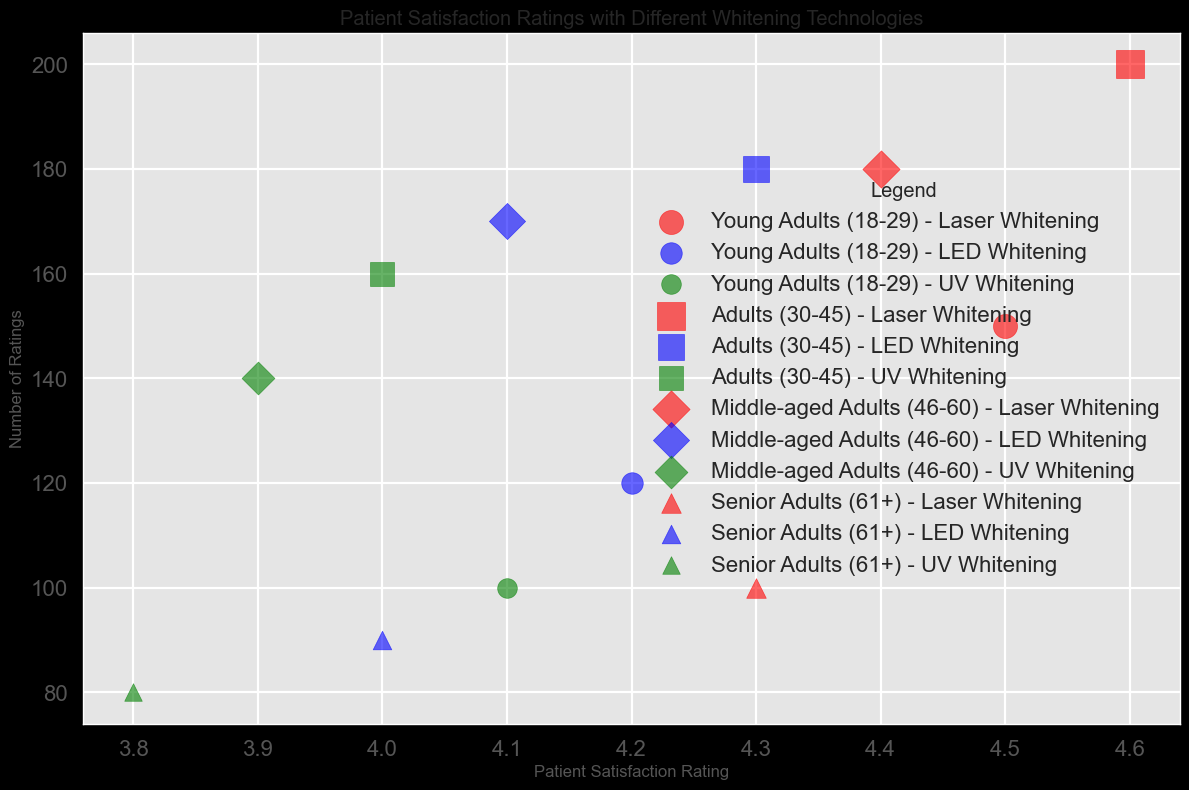What's the most popular whitening technology among Middle-aged Adults (46-60)? Look at the bubbles for "Middle-aged Adults (46-60)" and compare the sizes (Number of Ratings) for each whitening technology. The largest bubble indicates the most popular technology. "Laser Whitening" has the largest bubble with 180 ratings.
Answer: Laser Whitening How does the satisfaction rating for LED Whitening among Adults (30-45) compare to UV Whitening among the same group? Locate the satisfaction ratings for "LED Whitening" and "UV Whitening" within the "Adults (30-45)" demographic. The ratings are 4.3 for LED Whitening and 4.0 for UV Whitening. Compare them to see that 4.3 is greater than 4.0.
Answer: LED Whitening has a higher satisfaction rating Which demographic group has the highest satisfaction rating for UV Whitening? Look at the bubbles for "UV Whitening" and compare the satisfaction ratings across different demographic groups. The satisfaction ratings are 4.1 for Young Adults, 4.0 for Adults, 3.9 for Middle-aged Adults, and 3.8 for Senior Adults. The highest rating is 4.1 for Young Adults.
Answer: Young Adults (18-29) Which demographic group's satisfaction rating for Laser Whitening falls between 4.4 and 4.6? Locate the satisfaction ratings for "Laser Whitening" in each demographic group: 4.5 for Young Adults, 4.6 for Adults, 4.4 for Middle-aged Adults, and 4.3 for Senior Adults. The ratings between 4.4 and 4.6 are 4.5 and 4.4. The relevant groups are Young Adults and Middle-aged Adults.
Answer: Young Adults (18-29) and Middle-aged Adults (46-60) What is the average satisfaction rating for LED Whitening across all demographic groups? Sum the satisfaction ratings for "LED Whitening" across all groups: 4.2 (Young Adults) + 4.3 (Adults) + 4.1 (Middle-aged Adults) + 4.0 (Senior Adults) = 16.6. Divide the sum by the number of groups (4): 16.6 / 4 = 4.15.
Answer: 4.15 In terms of number of ratings, which demographic group contributes the least for UV Whitening? Look at the bubbles representing "UV Whitening" and compare their sizes (Number of Ratings). Sizes are 100 (Young Adults), 160 (Adults), 140 (Middle-aged Adults), and 80 (Senior Adults). The smallest size is 80, corresponding to Senior Adults.
Answer: Senior Adults (61+) If you sum the number of ratings for Laser Whitening and UV Whitening among Senior Adults (61+), what is the total? Add the number of ratings for "Laser Whitening" and "UV Whitening" within the "Senior Adults (61+)" group: 100 (Laser) + 80 (UV) = 180.
Answer: 180 Which whitening technology has the highest patient satisfaction rating overall? Compare the highest satisfaction ratings for each whitening technology: Laser Whitening (up to 4.6), LED Whitening (up to 4.3), UV Whitening (up to 4.1). The highest is 4.6 for Laser Whitening.
Answer: Laser Whitening 